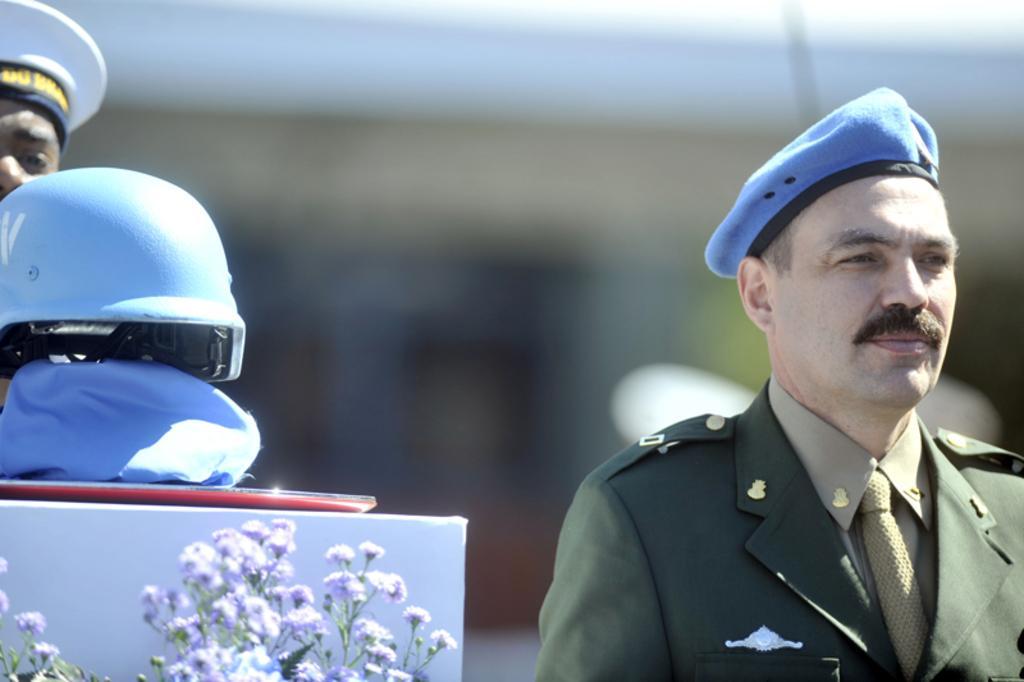Please provide a concise description of this image. On the left side, there is a helmet on an object, which is placed on a white colored surface and there are plants having flowers. Behind them, there is a person wearing a white color cap. On the right side, there is a person in uniform, wearing a blue color cap and watching something. And the background is blurred. 